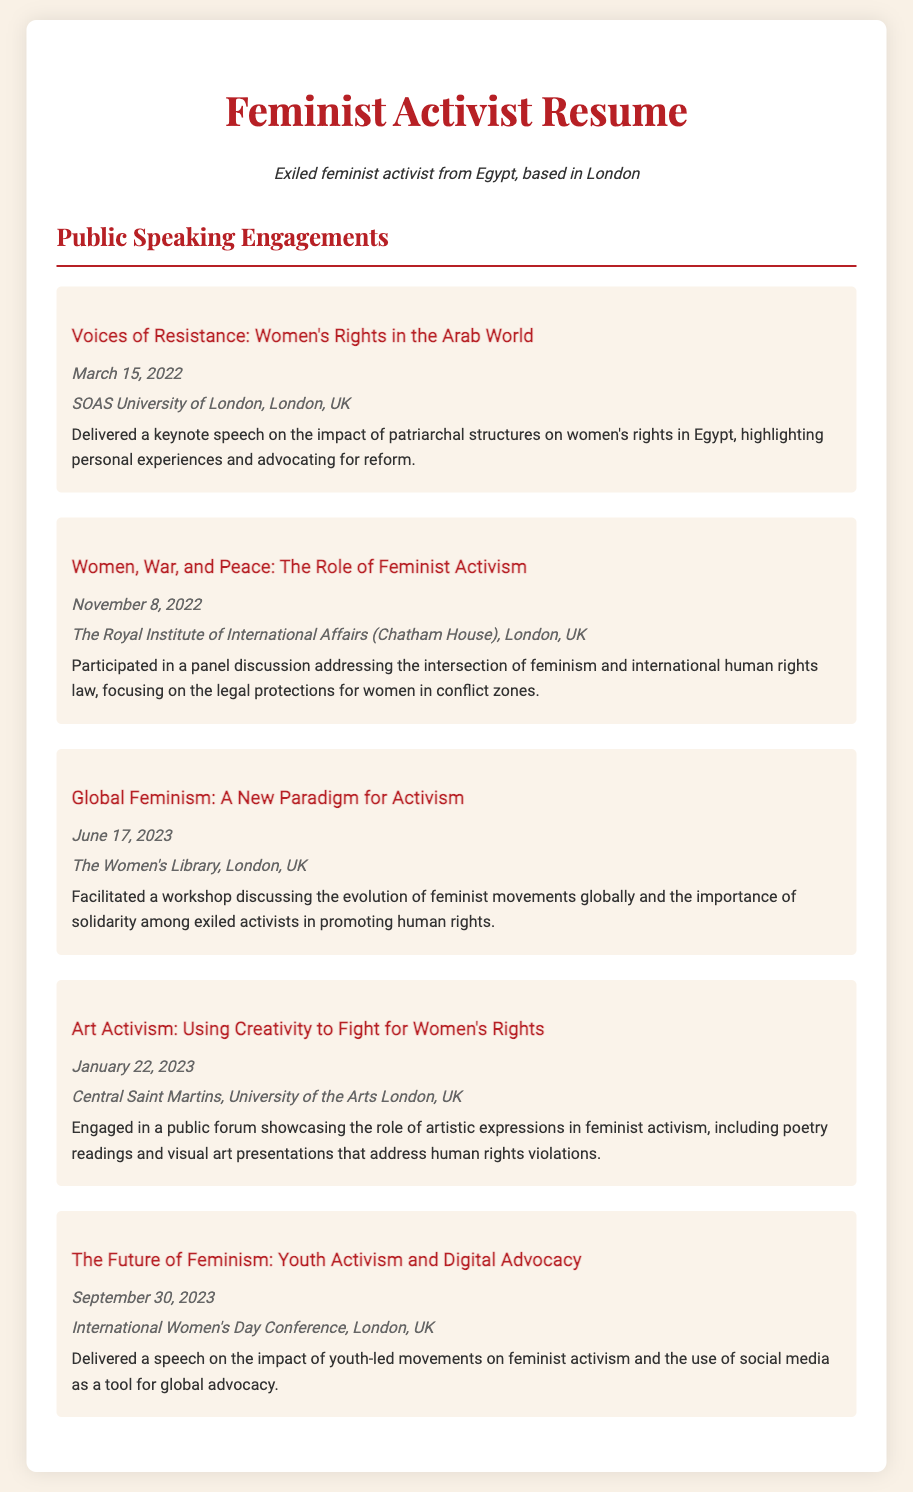What is the title of the keynote speech delivered on March 15, 2022? The title is explicitly mentioned in the document under the corresponding date.
Answer: Voices of Resistance: Women's Rights in the Arab World Where was the panel discussion on Women's Rights held? The location is specified in the section detailing that particular engagement.
Answer: The Royal Institute of International Affairs (Chatham House), London, UK What was the date of the workshop on Global Feminism? The date is provided in the section about the related engagement, providing clarity on when it took place.
Answer: June 17, 2023 What type of event was held on January 22, 2023? The document describes the nature of the engagement, indicating how it contributed to feminist activism.
Answer: Public forum What topic was discussed regarding youth activism on September 30, 2023? The focus of the speech is given in the description of that engagement, which outlines the key theme.
Answer: Impact of youth-led movements on feminist activism 